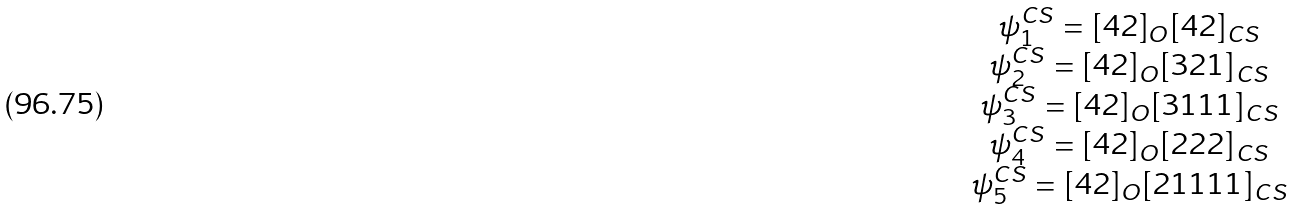<formula> <loc_0><loc_0><loc_500><loc_500>\begin{array} { c c c } \psi _ { 1 } ^ { C S } $ = $ [ 4 2 ] _ { O } [ 4 2 ] _ { C S } \\ \psi _ { 2 } ^ { C S } $ = $ [ 4 2 ] _ { O } [ 3 2 1 ] _ { C S } \\ \psi _ { 3 } ^ { C S } $ = $ [ 4 2 ] _ { O } [ 3 1 1 1 ] _ { C S } \\ \psi _ { 4 } ^ { C S } $ = $ [ 4 2 ] _ { O } [ 2 2 2 ] _ { C S } \\ \psi _ { 5 } ^ { C S } $ = $ [ 4 2 ] _ { O } [ 2 1 1 1 1 ] _ { C S } \end{array}</formula> 